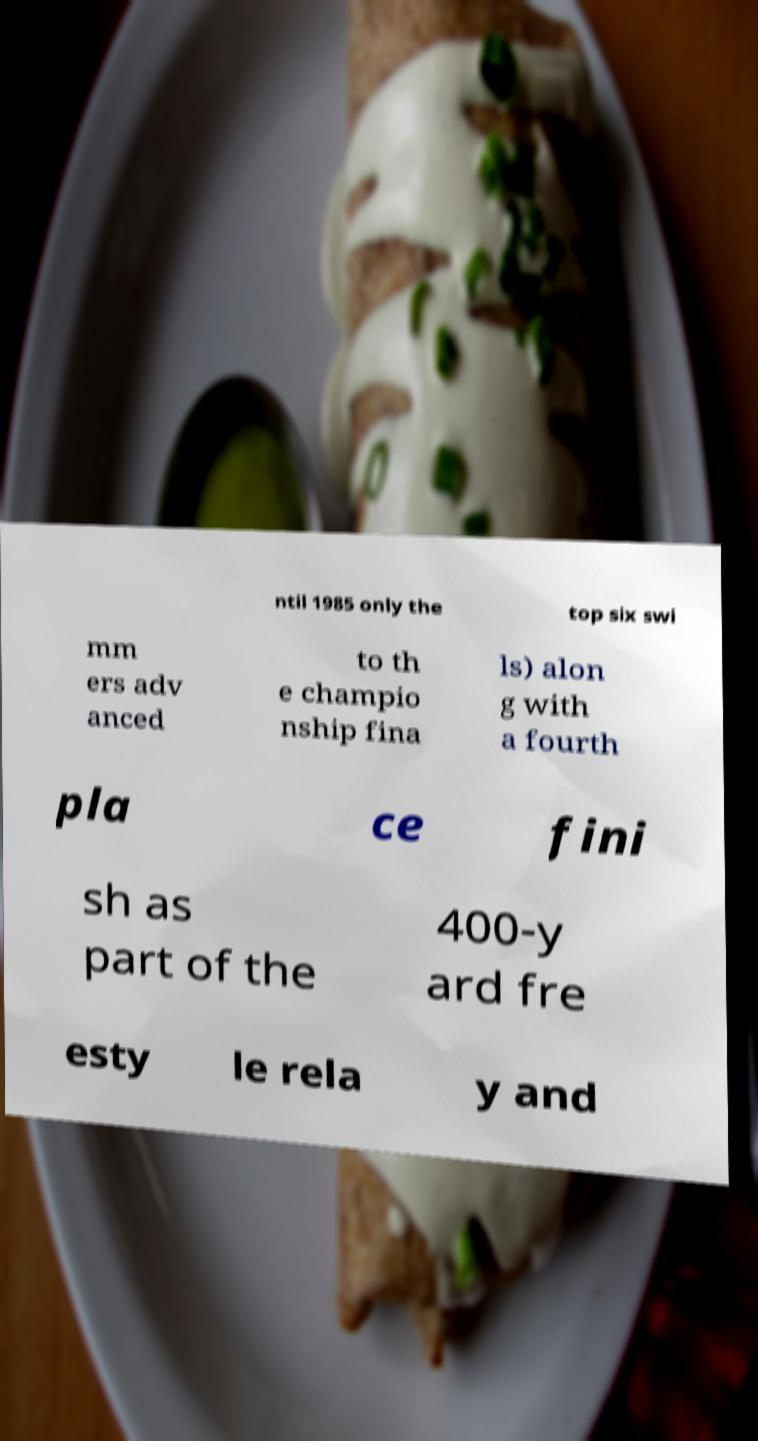What messages or text are displayed in this image? I need them in a readable, typed format. ntil 1985 only the top six swi mm ers adv anced to th e champio nship fina ls) alon g with a fourth pla ce fini sh as part of the 400-y ard fre esty le rela y and 